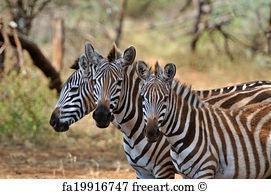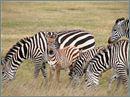The first image is the image on the left, the second image is the image on the right. For the images displayed, is the sentence "Each image contains exactly three foreground zebra that are close together in similar poses." factually correct? Answer yes or no. No. The first image is the image on the left, the second image is the image on the right. Assess this claim about the two images: "there are 6 zebras in the image pair". Correct or not? Answer yes or no. No. 